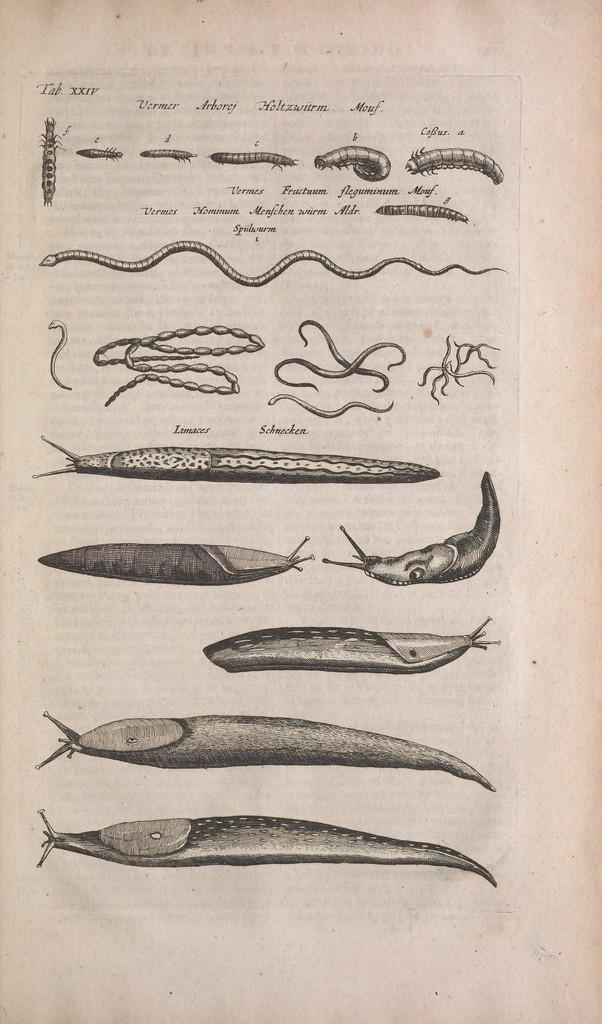What is present on the paper in the image? The paper contains text. What types of animals can be seen in the image? There are different types of fishes, snakes, and reptiles in the image. What is the color of the background in the image? The background of the image is white. What type of loaf is being used as a treatment for the snakes in the image? There is no loaf present in the image, and snakes are not being treated for anything. 